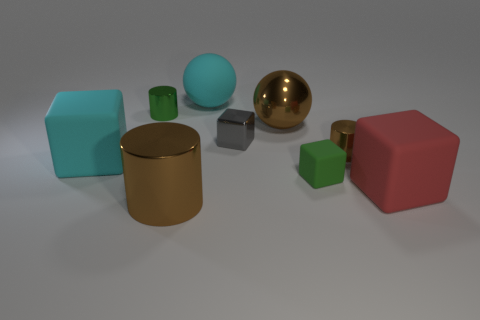How many other objects are there of the same shape as the gray thing?
Your response must be concise. 3. Is the green matte thing the same size as the gray metal cube?
Offer a terse response. Yes. Are any brown rubber cylinders visible?
Offer a very short reply. No. Are there any brown cylinders made of the same material as the tiny gray block?
Provide a short and direct response. Yes. There is a cyan cube that is the same size as the metallic ball; what is it made of?
Keep it short and to the point. Rubber. How many other tiny yellow things have the same shape as the small rubber thing?
Your answer should be compact. 0. What size is the green cube that is made of the same material as the large red cube?
Provide a succinct answer. Small. What material is the block that is right of the brown sphere and behind the big red block?
Your response must be concise. Rubber. What number of brown metallic objects are the same size as the red object?
Make the answer very short. 2. What material is the big cyan object that is the same shape as the green matte object?
Provide a succinct answer. Rubber. 